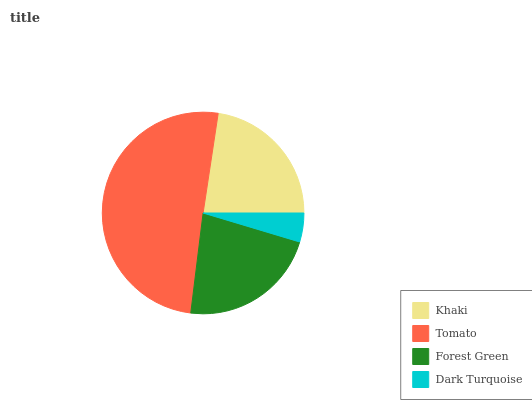Is Dark Turquoise the minimum?
Answer yes or no. Yes. Is Tomato the maximum?
Answer yes or no. Yes. Is Forest Green the minimum?
Answer yes or no. No. Is Forest Green the maximum?
Answer yes or no. No. Is Tomato greater than Forest Green?
Answer yes or no. Yes. Is Forest Green less than Tomato?
Answer yes or no. Yes. Is Forest Green greater than Tomato?
Answer yes or no. No. Is Tomato less than Forest Green?
Answer yes or no. No. Is Khaki the high median?
Answer yes or no. Yes. Is Forest Green the low median?
Answer yes or no. Yes. Is Tomato the high median?
Answer yes or no. No. Is Tomato the low median?
Answer yes or no. No. 